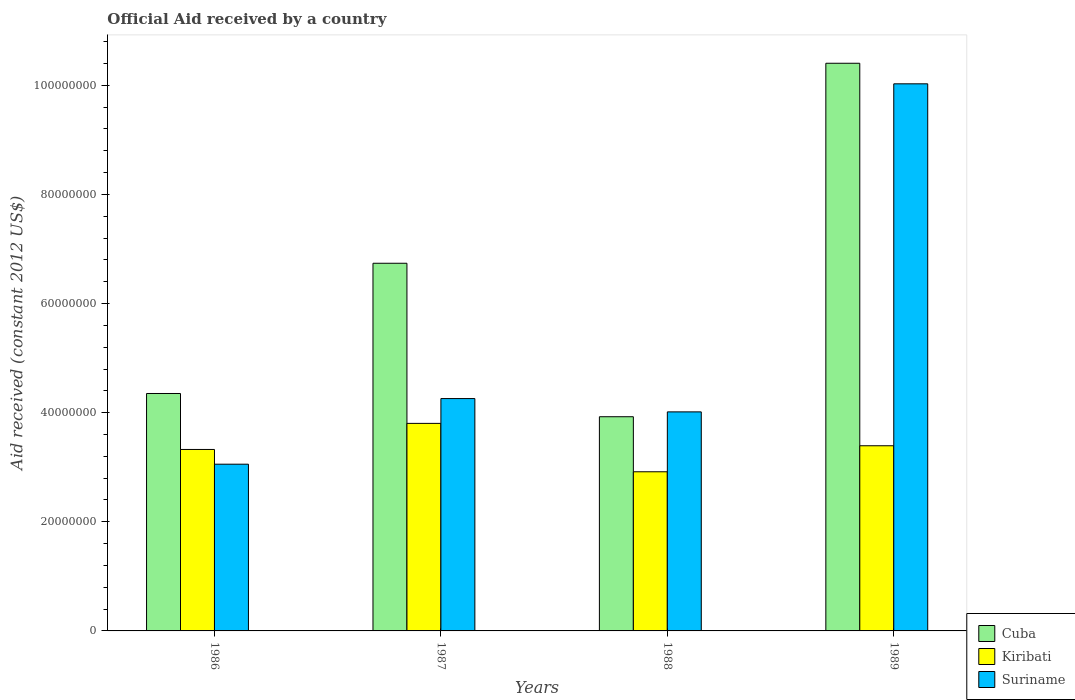How many different coloured bars are there?
Offer a very short reply. 3. How many groups of bars are there?
Your response must be concise. 4. How many bars are there on the 1st tick from the left?
Offer a very short reply. 3. How many bars are there on the 1st tick from the right?
Make the answer very short. 3. What is the net official aid received in Cuba in 1988?
Make the answer very short. 3.93e+07. Across all years, what is the maximum net official aid received in Suriname?
Offer a terse response. 1.00e+08. Across all years, what is the minimum net official aid received in Suriname?
Ensure brevity in your answer.  3.06e+07. What is the total net official aid received in Kiribati in the graph?
Provide a short and direct response. 1.34e+08. What is the difference between the net official aid received in Cuba in 1987 and that in 1989?
Give a very brief answer. -3.67e+07. What is the difference between the net official aid received in Kiribati in 1986 and the net official aid received in Suriname in 1989?
Provide a short and direct response. -6.70e+07. What is the average net official aid received in Suriname per year?
Provide a short and direct response. 5.34e+07. In the year 1986, what is the difference between the net official aid received in Kiribati and net official aid received in Suriname?
Provide a short and direct response. 2.70e+06. In how many years, is the net official aid received in Kiribati greater than 60000000 US$?
Provide a short and direct response. 0. What is the ratio of the net official aid received in Suriname in 1986 to that in 1989?
Your answer should be very brief. 0.3. Is the net official aid received in Kiribati in 1986 less than that in 1987?
Make the answer very short. Yes. What is the difference between the highest and the second highest net official aid received in Kiribati?
Your answer should be compact. 4.10e+06. What is the difference between the highest and the lowest net official aid received in Suriname?
Your response must be concise. 6.97e+07. What does the 3rd bar from the left in 1988 represents?
Make the answer very short. Suriname. What does the 1st bar from the right in 1989 represents?
Give a very brief answer. Suriname. What is the difference between two consecutive major ticks on the Y-axis?
Ensure brevity in your answer.  2.00e+07. Does the graph contain grids?
Your response must be concise. No. How many legend labels are there?
Ensure brevity in your answer.  3. How are the legend labels stacked?
Ensure brevity in your answer.  Vertical. What is the title of the graph?
Provide a succinct answer. Official Aid received by a country. What is the label or title of the X-axis?
Your answer should be very brief. Years. What is the label or title of the Y-axis?
Provide a short and direct response. Aid received (constant 2012 US$). What is the Aid received (constant 2012 US$) in Cuba in 1986?
Keep it short and to the point. 4.35e+07. What is the Aid received (constant 2012 US$) of Kiribati in 1986?
Provide a short and direct response. 3.33e+07. What is the Aid received (constant 2012 US$) in Suriname in 1986?
Give a very brief answer. 3.06e+07. What is the Aid received (constant 2012 US$) of Cuba in 1987?
Ensure brevity in your answer.  6.74e+07. What is the Aid received (constant 2012 US$) of Kiribati in 1987?
Your answer should be compact. 3.80e+07. What is the Aid received (constant 2012 US$) in Suriname in 1987?
Keep it short and to the point. 4.26e+07. What is the Aid received (constant 2012 US$) in Cuba in 1988?
Offer a very short reply. 3.93e+07. What is the Aid received (constant 2012 US$) of Kiribati in 1988?
Offer a terse response. 2.92e+07. What is the Aid received (constant 2012 US$) in Suriname in 1988?
Provide a succinct answer. 4.02e+07. What is the Aid received (constant 2012 US$) in Cuba in 1989?
Keep it short and to the point. 1.04e+08. What is the Aid received (constant 2012 US$) in Kiribati in 1989?
Give a very brief answer. 3.39e+07. What is the Aid received (constant 2012 US$) in Suriname in 1989?
Make the answer very short. 1.00e+08. Across all years, what is the maximum Aid received (constant 2012 US$) in Cuba?
Keep it short and to the point. 1.04e+08. Across all years, what is the maximum Aid received (constant 2012 US$) of Kiribati?
Provide a succinct answer. 3.80e+07. Across all years, what is the maximum Aid received (constant 2012 US$) in Suriname?
Provide a short and direct response. 1.00e+08. Across all years, what is the minimum Aid received (constant 2012 US$) of Cuba?
Ensure brevity in your answer.  3.93e+07. Across all years, what is the minimum Aid received (constant 2012 US$) in Kiribati?
Provide a succinct answer. 2.92e+07. Across all years, what is the minimum Aid received (constant 2012 US$) of Suriname?
Make the answer very short. 3.06e+07. What is the total Aid received (constant 2012 US$) in Cuba in the graph?
Your response must be concise. 2.54e+08. What is the total Aid received (constant 2012 US$) in Kiribati in the graph?
Your answer should be very brief. 1.34e+08. What is the total Aid received (constant 2012 US$) in Suriname in the graph?
Your answer should be very brief. 2.14e+08. What is the difference between the Aid received (constant 2012 US$) of Cuba in 1986 and that in 1987?
Your answer should be very brief. -2.39e+07. What is the difference between the Aid received (constant 2012 US$) of Kiribati in 1986 and that in 1987?
Provide a succinct answer. -4.78e+06. What is the difference between the Aid received (constant 2012 US$) in Suriname in 1986 and that in 1987?
Make the answer very short. -1.20e+07. What is the difference between the Aid received (constant 2012 US$) in Cuba in 1986 and that in 1988?
Make the answer very short. 4.26e+06. What is the difference between the Aid received (constant 2012 US$) in Kiribati in 1986 and that in 1988?
Keep it short and to the point. 4.09e+06. What is the difference between the Aid received (constant 2012 US$) in Suriname in 1986 and that in 1988?
Your answer should be very brief. -9.59e+06. What is the difference between the Aid received (constant 2012 US$) of Cuba in 1986 and that in 1989?
Keep it short and to the point. -6.05e+07. What is the difference between the Aid received (constant 2012 US$) of Kiribati in 1986 and that in 1989?
Your answer should be very brief. -6.80e+05. What is the difference between the Aid received (constant 2012 US$) in Suriname in 1986 and that in 1989?
Your response must be concise. -6.97e+07. What is the difference between the Aid received (constant 2012 US$) of Cuba in 1987 and that in 1988?
Provide a short and direct response. 2.81e+07. What is the difference between the Aid received (constant 2012 US$) in Kiribati in 1987 and that in 1988?
Ensure brevity in your answer.  8.87e+06. What is the difference between the Aid received (constant 2012 US$) in Suriname in 1987 and that in 1988?
Provide a short and direct response. 2.44e+06. What is the difference between the Aid received (constant 2012 US$) in Cuba in 1987 and that in 1989?
Offer a very short reply. -3.67e+07. What is the difference between the Aid received (constant 2012 US$) in Kiribati in 1987 and that in 1989?
Your answer should be very brief. 4.10e+06. What is the difference between the Aid received (constant 2012 US$) in Suriname in 1987 and that in 1989?
Your answer should be compact. -5.77e+07. What is the difference between the Aid received (constant 2012 US$) of Cuba in 1988 and that in 1989?
Provide a succinct answer. -6.48e+07. What is the difference between the Aid received (constant 2012 US$) in Kiribati in 1988 and that in 1989?
Ensure brevity in your answer.  -4.77e+06. What is the difference between the Aid received (constant 2012 US$) of Suriname in 1988 and that in 1989?
Offer a terse response. -6.01e+07. What is the difference between the Aid received (constant 2012 US$) in Cuba in 1986 and the Aid received (constant 2012 US$) in Kiribati in 1987?
Your answer should be compact. 5.48e+06. What is the difference between the Aid received (constant 2012 US$) of Cuba in 1986 and the Aid received (constant 2012 US$) of Suriname in 1987?
Ensure brevity in your answer.  9.30e+05. What is the difference between the Aid received (constant 2012 US$) in Kiribati in 1986 and the Aid received (constant 2012 US$) in Suriname in 1987?
Give a very brief answer. -9.33e+06. What is the difference between the Aid received (constant 2012 US$) of Cuba in 1986 and the Aid received (constant 2012 US$) of Kiribati in 1988?
Ensure brevity in your answer.  1.44e+07. What is the difference between the Aid received (constant 2012 US$) of Cuba in 1986 and the Aid received (constant 2012 US$) of Suriname in 1988?
Make the answer very short. 3.37e+06. What is the difference between the Aid received (constant 2012 US$) in Kiribati in 1986 and the Aid received (constant 2012 US$) in Suriname in 1988?
Your answer should be very brief. -6.89e+06. What is the difference between the Aid received (constant 2012 US$) of Cuba in 1986 and the Aid received (constant 2012 US$) of Kiribati in 1989?
Make the answer very short. 9.58e+06. What is the difference between the Aid received (constant 2012 US$) in Cuba in 1986 and the Aid received (constant 2012 US$) in Suriname in 1989?
Your response must be concise. -5.68e+07. What is the difference between the Aid received (constant 2012 US$) in Kiribati in 1986 and the Aid received (constant 2012 US$) in Suriname in 1989?
Keep it short and to the point. -6.70e+07. What is the difference between the Aid received (constant 2012 US$) of Cuba in 1987 and the Aid received (constant 2012 US$) of Kiribati in 1988?
Make the answer very short. 3.82e+07. What is the difference between the Aid received (constant 2012 US$) of Cuba in 1987 and the Aid received (constant 2012 US$) of Suriname in 1988?
Offer a terse response. 2.72e+07. What is the difference between the Aid received (constant 2012 US$) in Kiribati in 1987 and the Aid received (constant 2012 US$) in Suriname in 1988?
Make the answer very short. -2.11e+06. What is the difference between the Aid received (constant 2012 US$) of Cuba in 1987 and the Aid received (constant 2012 US$) of Kiribati in 1989?
Keep it short and to the point. 3.34e+07. What is the difference between the Aid received (constant 2012 US$) in Cuba in 1987 and the Aid received (constant 2012 US$) in Suriname in 1989?
Keep it short and to the point. -3.29e+07. What is the difference between the Aid received (constant 2012 US$) in Kiribati in 1987 and the Aid received (constant 2012 US$) in Suriname in 1989?
Give a very brief answer. -6.22e+07. What is the difference between the Aid received (constant 2012 US$) in Cuba in 1988 and the Aid received (constant 2012 US$) in Kiribati in 1989?
Your answer should be very brief. 5.32e+06. What is the difference between the Aid received (constant 2012 US$) in Cuba in 1988 and the Aid received (constant 2012 US$) in Suriname in 1989?
Give a very brief answer. -6.10e+07. What is the difference between the Aid received (constant 2012 US$) in Kiribati in 1988 and the Aid received (constant 2012 US$) in Suriname in 1989?
Give a very brief answer. -7.11e+07. What is the average Aid received (constant 2012 US$) of Cuba per year?
Offer a very short reply. 6.36e+07. What is the average Aid received (constant 2012 US$) in Kiribati per year?
Offer a very short reply. 3.36e+07. What is the average Aid received (constant 2012 US$) of Suriname per year?
Your response must be concise. 5.34e+07. In the year 1986, what is the difference between the Aid received (constant 2012 US$) of Cuba and Aid received (constant 2012 US$) of Kiribati?
Your answer should be very brief. 1.03e+07. In the year 1986, what is the difference between the Aid received (constant 2012 US$) in Cuba and Aid received (constant 2012 US$) in Suriname?
Your answer should be compact. 1.30e+07. In the year 1986, what is the difference between the Aid received (constant 2012 US$) in Kiribati and Aid received (constant 2012 US$) in Suriname?
Ensure brevity in your answer.  2.70e+06. In the year 1987, what is the difference between the Aid received (constant 2012 US$) in Cuba and Aid received (constant 2012 US$) in Kiribati?
Your answer should be compact. 2.94e+07. In the year 1987, what is the difference between the Aid received (constant 2012 US$) in Cuba and Aid received (constant 2012 US$) in Suriname?
Offer a very short reply. 2.48e+07. In the year 1987, what is the difference between the Aid received (constant 2012 US$) in Kiribati and Aid received (constant 2012 US$) in Suriname?
Offer a terse response. -4.55e+06. In the year 1988, what is the difference between the Aid received (constant 2012 US$) of Cuba and Aid received (constant 2012 US$) of Kiribati?
Your answer should be compact. 1.01e+07. In the year 1988, what is the difference between the Aid received (constant 2012 US$) of Cuba and Aid received (constant 2012 US$) of Suriname?
Make the answer very short. -8.90e+05. In the year 1988, what is the difference between the Aid received (constant 2012 US$) in Kiribati and Aid received (constant 2012 US$) in Suriname?
Offer a terse response. -1.10e+07. In the year 1989, what is the difference between the Aid received (constant 2012 US$) of Cuba and Aid received (constant 2012 US$) of Kiribati?
Make the answer very short. 7.01e+07. In the year 1989, what is the difference between the Aid received (constant 2012 US$) in Cuba and Aid received (constant 2012 US$) in Suriname?
Your answer should be very brief. 3.77e+06. In the year 1989, what is the difference between the Aid received (constant 2012 US$) in Kiribati and Aid received (constant 2012 US$) in Suriname?
Make the answer very short. -6.63e+07. What is the ratio of the Aid received (constant 2012 US$) of Cuba in 1986 to that in 1987?
Provide a succinct answer. 0.65. What is the ratio of the Aid received (constant 2012 US$) in Kiribati in 1986 to that in 1987?
Your response must be concise. 0.87. What is the ratio of the Aid received (constant 2012 US$) in Suriname in 1986 to that in 1987?
Provide a succinct answer. 0.72. What is the ratio of the Aid received (constant 2012 US$) in Cuba in 1986 to that in 1988?
Provide a short and direct response. 1.11. What is the ratio of the Aid received (constant 2012 US$) of Kiribati in 1986 to that in 1988?
Your answer should be compact. 1.14. What is the ratio of the Aid received (constant 2012 US$) in Suriname in 1986 to that in 1988?
Give a very brief answer. 0.76. What is the ratio of the Aid received (constant 2012 US$) of Cuba in 1986 to that in 1989?
Your answer should be very brief. 0.42. What is the ratio of the Aid received (constant 2012 US$) in Suriname in 1986 to that in 1989?
Your answer should be compact. 0.3. What is the ratio of the Aid received (constant 2012 US$) of Cuba in 1987 to that in 1988?
Your answer should be very brief. 1.72. What is the ratio of the Aid received (constant 2012 US$) of Kiribati in 1987 to that in 1988?
Keep it short and to the point. 1.3. What is the ratio of the Aid received (constant 2012 US$) of Suriname in 1987 to that in 1988?
Offer a terse response. 1.06. What is the ratio of the Aid received (constant 2012 US$) in Cuba in 1987 to that in 1989?
Offer a terse response. 0.65. What is the ratio of the Aid received (constant 2012 US$) in Kiribati in 1987 to that in 1989?
Your response must be concise. 1.12. What is the ratio of the Aid received (constant 2012 US$) in Suriname in 1987 to that in 1989?
Offer a terse response. 0.42. What is the ratio of the Aid received (constant 2012 US$) of Cuba in 1988 to that in 1989?
Offer a terse response. 0.38. What is the ratio of the Aid received (constant 2012 US$) in Kiribati in 1988 to that in 1989?
Your response must be concise. 0.86. What is the ratio of the Aid received (constant 2012 US$) of Suriname in 1988 to that in 1989?
Keep it short and to the point. 0.4. What is the difference between the highest and the second highest Aid received (constant 2012 US$) of Cuba?
Keep it short and to the point. 3.67e+07. What is the difference between the highest and the second highest Aid received (constant 2012 US$) of Kiribati?
Make the answer very short. 4.10e+06. What is the difference between the highest and the second highest Aid received (constant 2012 US$) in Suriname?
Keep it short and to the point. 5.77e+07. What is the difference between the highest and the lowest Aid received (constant 2012 US$) in Cuba?
Offer a terse response. 6.48e+07. What is the difference between the highest and the lowest Aid received (constant 2012 US$) in Kiribati?
Your response must be concise. 8.87e+06. What is the difference between the highest and the lowest Aid received (constant 2012 US$) of Suriname?
Provide a short and direct response. 6.97e+07. 